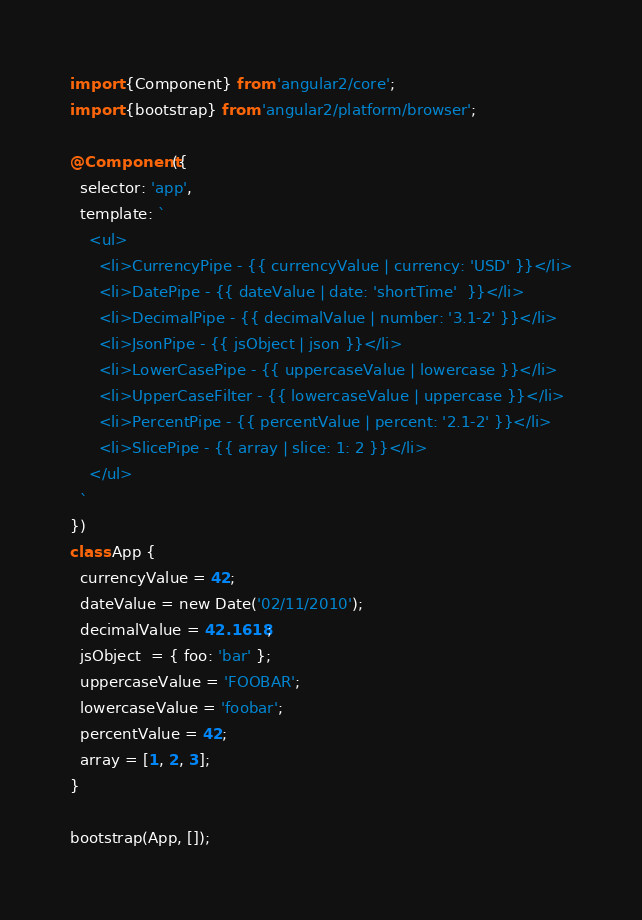Convert code to text. <code><loc_0><loc_0><loc_500><loc_500><_TypeScript_>import {Component} from 'angular2/core';
import {bootstrap} from 'angular2/platform/browser';

@Component({
  selector: 'app',
  template: `
    <ul>
      <li>CurrencyPipe - {{ currencyValue | currency: 'USD' }}</li>
      <li>DatePipe - {{ dateValue | date: 'shortTime'  }}</li>
      <li>DecimalPipe - {{ decimalValue | number: '3.1-2' }}</li>
      <li>JsonPipe - {{ jsObject | json }}</li>
      <li>LowerCasePipe - {{ uppercaseValue | lowercase }}</li>
      <li>UpperCaseFilter - {{ lowercaseValue | uppercase }}</li>
      <li>PercentPipe - {{ percentValue | percent: '2.1-2' }}</li>
      <li>SlicePipe - {{ array | slice: 1: 2 }}</li>
    </ul>
  `
})
class App {
  currencyValue = 42;
  dateValue = new Date('02/11/2010');
  decimalValue = 42.1618;
  jsObject  = { foo: 'bar' };
  uppercaseValue = 'FOOBAR';
  lowercaseValue = 'foobar';
  percentValue = 42;
  array = [1, 2, 3];
}

bootstrap(App, []);
</code> 